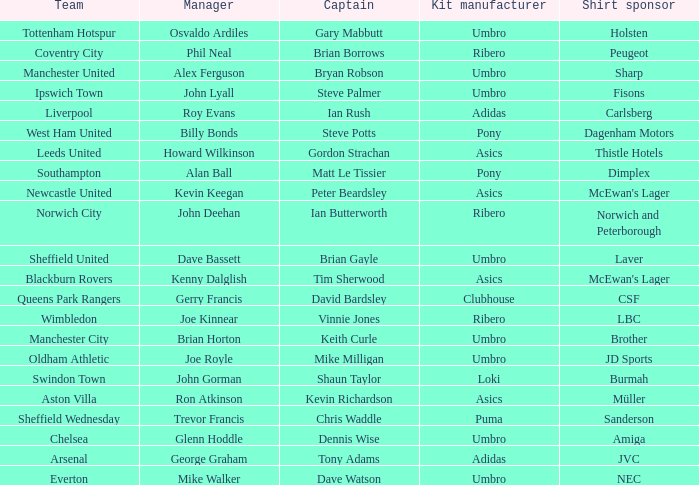Which captain has howard wilkinson as the manager? Gordon Strachan. 